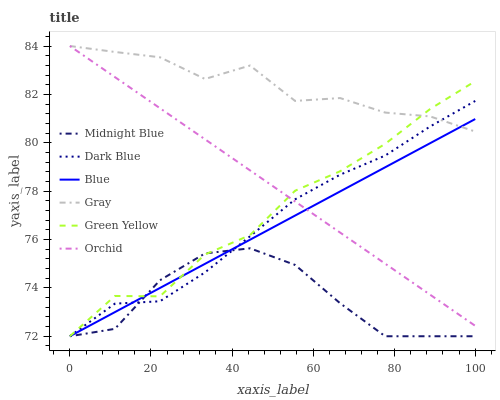Does Midnight Blue have the minimum area under the curve?
Answer yes or no. Yes. Does Gray have the maximum area under the curve?
Answer yes or no. Yes. Does Gray have the minimum area under the curve?
Answer yes or no. No. Does Midnight Blue have the maximum area under the curve?
Answer yes or no. No. Is Orchid the smoothest?
Answer yes or no. Yes. Is Gray the roughest?
Answer yes or no. Yes. Is Midnight Blue the smoothest?
Answer yes or no. No. Is Midnight Blue the roughest?
Answer yes or no. No. Does Gray have the lowest value?
Answer yes or no. No. Does Midnight Blue have the highest value?
Answer yes or no. No. Is Midnight Blue less than Orchid?
Answer yes or no. Yes. Is Orchid greater than Midnight Blue?
Answer yes or no. Yes. Does Midnight Blue intersect Orchid?
Answer yes or no. No. 